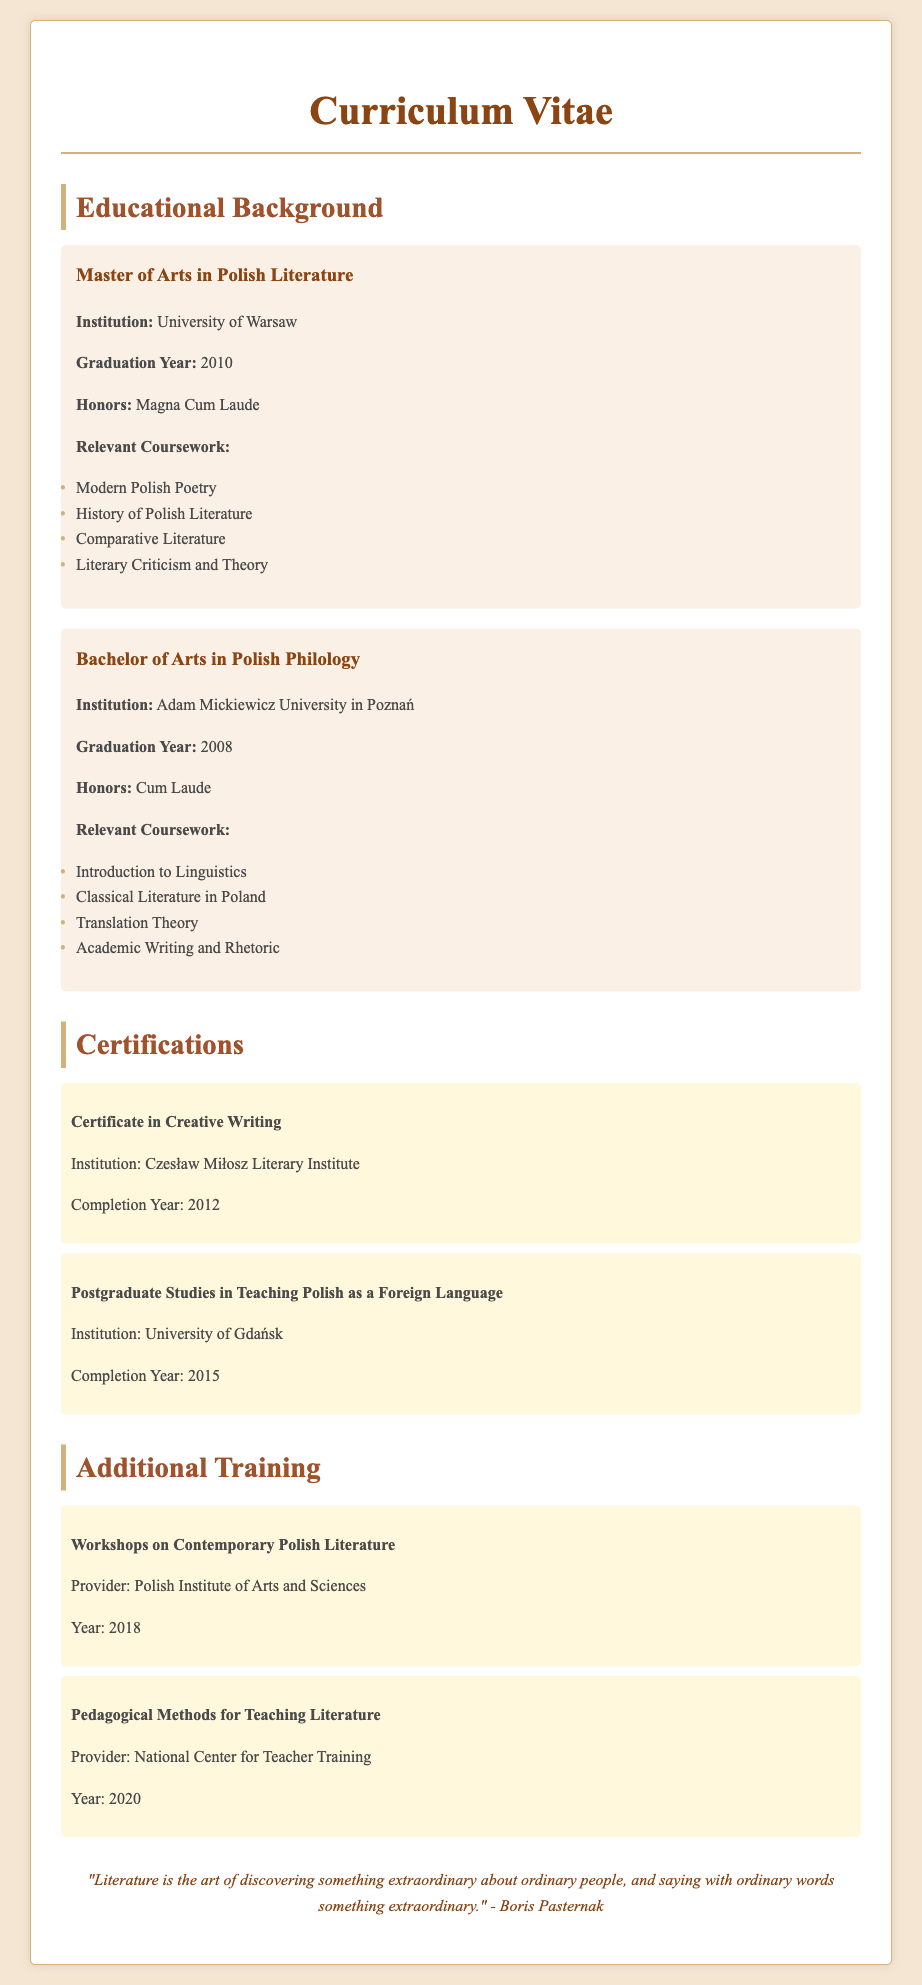what is the highest honor received for the Master of Arts in Polish Literature? The document specifies that the highest honor received is "Magna Cum Laude."
Answer: Magna Cum Laude which university awarded a Bachelor of Arts in Polish Philology? The Bachelor of Arts in Polish Philology was awarded by Adam Mickiewicz University in Poznań.
Answer: Adam Mickiewicz University in Poznań in what year did the individual graduate with a Master's degree? The graduation year for the Master's degree is stated as 2010.
Answer: 2010 what type of certification was completed in 2012? The document lists a "Certificate in Creative Writing" as the certification completed in 2012.
Answer: Certificate in Creative Writing how many relevant courses are listed for the Bachelor of Arts in Polish Philology? There are four relevant courses listed under the Bachelor of Arts in Polish Philology.
Answer: 4 what training program relates to teaching methods for literature? The program mentioned that relates to teaching methods is titled "Pedagogical Methods for Teaching Literature."
Answer: Pedagogical Methods for Teaching Literature what is the institution of the postgraduate studies completed in 2015? The document indicates that the institution for the postgraduate studies is the University of Gdańsk.
Answer: University of Gdańsk name one of the workshops attended in 2018. The document notes workshops on "Contemporary Polish Literature" were attended in 2018.
Answer: Contemporary Polish Literature what year was the Bachelor of Arts degree earned? The year noted for earning the Bachelor of Arts degree is 2008.
Answer: 2008 